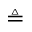Convert formula to latex. <formula><loc_0><loc_0><loc_500><loc_500>\triangle q</formula> 